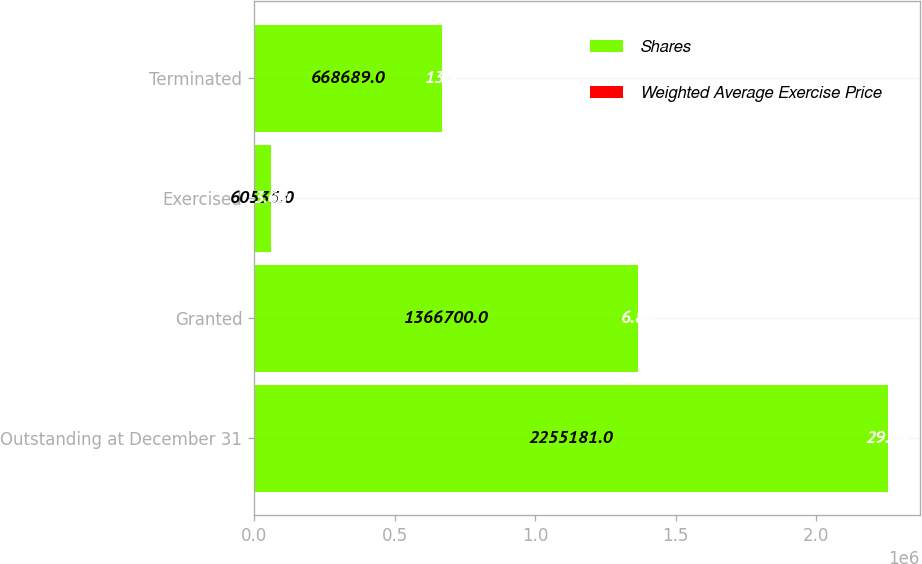<chart> <loc_0><loc_0><loc_500><loc_500><stacked_bar_chart><ecel><fcel>Outstanding at December 31<fcel>Granted<fcel>Exercised<fcel>Terminated<nl><fcel>Shares<fcel>2.25518e+06<fcel>1.3667e+06<fcel>60535<fcel>668689<nl><fcel>Weighted Average Exercise Price<fcel>29.01<fcel>6.86<fcel>3.68<fcel>13.2<nl></chart> 